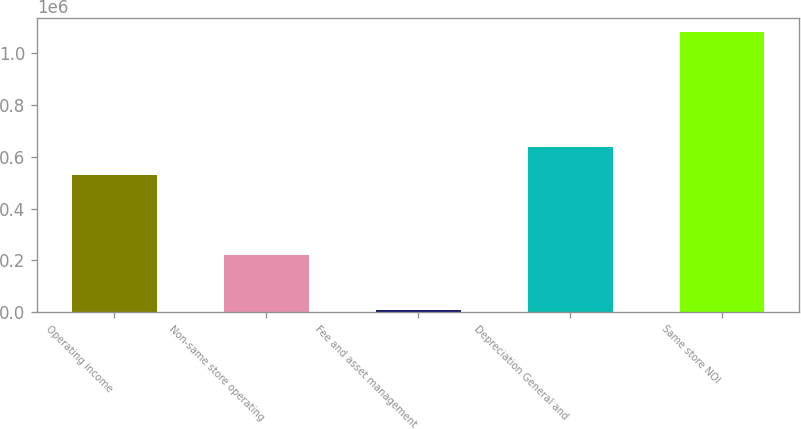<chart> <loc_0><loc_0><loc_500><loc_500><bar_chart><fcel>Operating income<fcel>Non-same store operating<fcel>Fee and asset management<fcel>Depreciation General and<fcel>Same store NOI<nl><fcel>529390<fcel>222311<fcel>7519<fcel>636786<fcel>1.08148e+06<nl></chart> 